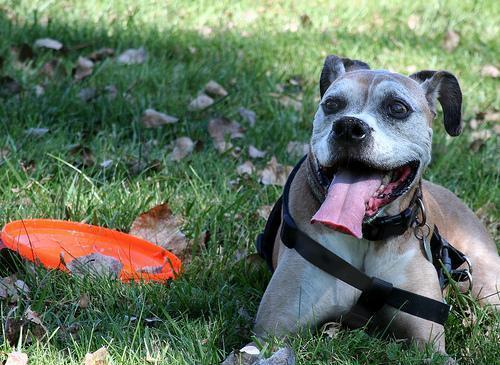How many dogs are there?
Give a very brief answer. 1. 